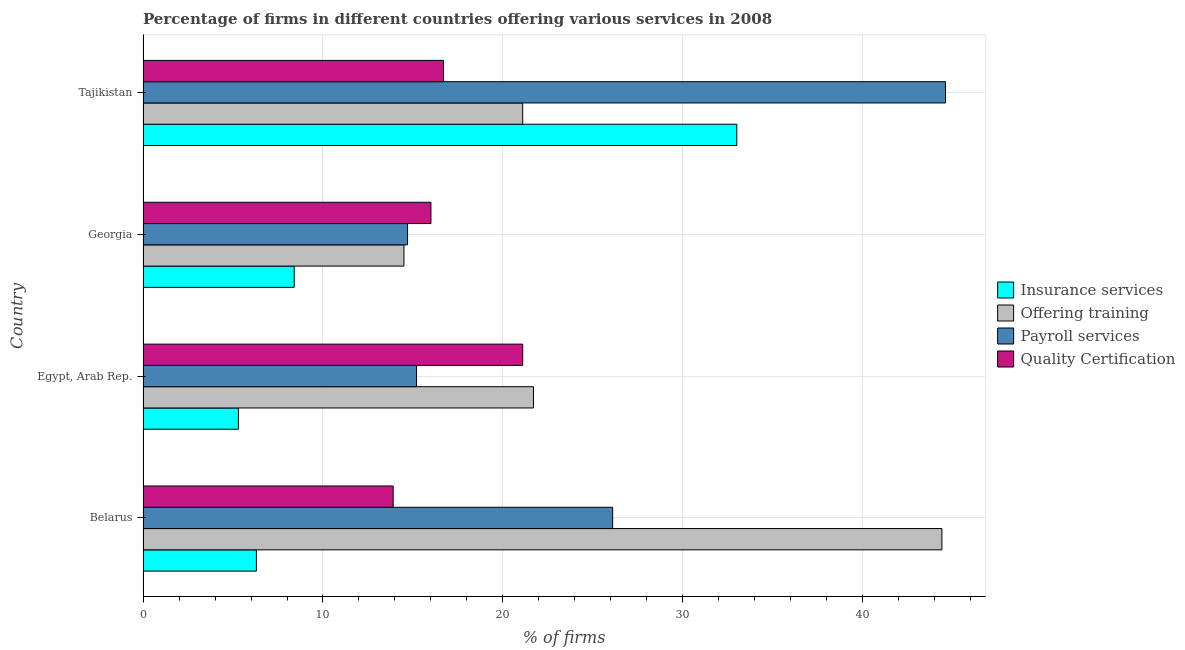How many different coloured bars are there?
Give a very brief answer. 4. Are the number of bars on each tick of the Y-axis equal?
Give a very brief answer. Yes. How many bars are there on the 4th tick from the bottom?
Ensure brevity in your answer.  4. What is the label of the 4th group of bars from the top?
Keep it short and to the point. Belarus. What is the percentage of firms offering quality certification in Tajikistan?
Your response must be concise. 16.7. Across all countries, what is the maximum percentage of firms offering quality certification?
Offer a very short reply. 21.1. Across all countries, what is the minimum percentage of firms offering insurance services?
Make the answer very short. 5.3. In which country was the percentage of firms offering insurance services maximum?
Give a very brief answer. Tajikistan. In which country was the percentage of firms offering quality certification minimum?
Offer a very short reply. Belarus. What is the total percentage of firms offering quality certification in the graph?
Offer a very short reply. 67.7. What is the difference between the percentage of firms offering training in Georgia and that in Tajikistan?
Your answer should be very brief. -6.6. What is the difference between the percentage of firms offering quality certification in Georgia and the percentage of firms offering training in Belarus?
Make the answer very short. -28.4. What is the average percentage of firms offering training per country?
Make the answer very short. 25.43. What is the ratio of the percentage of firms offering payroll services in Belarus to that in Georgia?
Offer a terse response. 1.78. What is the difference between the highest and the lowest percentage of firms offering payroll services?
Make the answer very short. 29.9. Is it the case that in every country, the sum of the percentage of firms offering payroll services and percentage of firms offering quality certification is greater than the sum of percentage of firms offering insurance services and percentage of firms offering training?
Offer a very short reply. Yes. What does the 2nd bar from the top in Belarus represents?
Offer a terse response. Payroll services. What does the 4th bar from the bottom in Tajikistan represents?
Your answer should be very brief. Quality Certification. Is it the case that in every country, the sum of the percentage of firms offering insurance services and percentage of firms offering training is greater than the percentage of firms offering payroll services?
Provide a short and direct response. Yes. How many bars are there?
Offer a terse response. 16. Are all the bars in the graph horizontal?
Ensure brevity in your answer.  Yes. Does the graph contain any zero values?
Keep it short and to the point. No. Does the graph contain grids?
Offer a very short reply. Yes. Where does the legend appear in the graph?
Offer a terse response. Center right. How many legend labels are there?
Give a very brief answer. 4. What is the title of the graph?
Make the answer very short. Percentage of firms in different countries offering various services in 2008. What is the label or title of the X-axis?
Keep it short and to the point. % of firms. What is the label or title of the Y-axis?
Keep it short and to the point. Country. What is the % of firms in Insurance services in Belarus?
Make the answer very short. 6.3. What is the % of firms in Offering training in Belarus?
Offer a terse response. 44.4. What is the % of firms in Payroll services in Belarus?
Your answer should be compact. 26.1. What is the % of firms in Offering training in Egypt, Arab Rep.?
Provide a short and direct response. 21.7. What is the % of firms in Quality Certification in Egypt, Arab Rep.?
Provide a short and direct response. 21.1. What is the % of firms of Insurance services in Georgia?
Provide a short and direct response. 8.4. What is the % of firms of Offering training in Georgia?
Make the answer very short. 14.5. What is the % of firms of Quality Certification in Georgia?
Keep it short and to the point. 16. What is the % of firms in Offering training in Tajikistan?
Your answer should be compact. 21.1. What is the % of firms of Payroll services in Tajikistan?
Provide a short and direct response. 44.6. Across all countries, what is the maximum % of firms in Insurance services?
Ensure brevity in your answer.  33. Across all countries, what is the maximum % of firms of Offering training?
Offer a terse response. 44.4. Across all countries, what is the maximum % of firms of Payroll services?
Give a very brief answer. 44.6. Across all countries, what is the maximum % of firms in Quality Certification?
Provide a short and direct response. 21.1. What is the total % of firms in Offering training in the graph?
Give a very brief answer. 101.7. What is the total % of firms in Payroll services in the graph?
Provide a succinct answer. 100.6. What is the total % of firms of Quality Certification in the graph?
Your answer should be compact. 67.7. What is the difference between the % of firms of Insurance services in Belarus and that in Egypt, Arab Rep.?
Provide a short and direct response. 1. What is the difference between the % of firms in Offering training in Belarus and that in Egypt, Arab Rep.?
Make the answer very short. 22.7. What is the difference between the % of firms of Payroll services in Belarus and that in Egypt, Arab Rep.?
Your response must be concise. 10.9. What is the difference between the % of firms in Offering training in Belarus and that in Georgia?
Keep it short and to the point. 29.9. What is the difference between the % of firms of Quality Certification in Belarus and that in Georgia?
Your response must be concise. -2.1. What is the difference between the % of firms in Insurance services in Belarus and that in Tajikistan?
Make the answer very short. -26.7. What is the difference between the % of firms in Offering training in Belarus and that in Tajikistan?
Your response must be concise. 23.3. What is the difference between the % of firms in Payroll services in Belarus and that in Tajikistan?
Make the answer very short. -18.5. What is the difference between the % of firms of Quality Certification in Belarus and that in Tajikistan?
Your answer should be compact. -2.8. What is the difference between the % of firms in Offering training in Egypt, Arab Rep. and that in Georgia?
Your response must be concise. 7.2. What is the difference between the % of firms of Payroll services in Egypt, Arab Rep. and that in Georgia?
Your answer should be very brief. 0.5. What is the difference between the % of firms in Insurance services in Egypt, Arab Rep. and that in Tajikistan?
Your answer should be compact. -27.7. What is the difference between the % of firms of Offering training in Egypt, Arab Rep. and that in Tajikistan?
Provide a short and direct response. 0.6. What is the difference between the % of firms in Payroll services in Egypt, Arab Rep. and that in Tajikistan?
Offer a terse response. -29.4. What is the difference between the % of firms of Insurance services in Georgia and that in Tajikistan?
Offer a very short reply. -24.6. What is the difference between the % of firms of Payroll services in Georgia and that in Tajikistan?
Give a very brief answer. -29.9. What is the difference between the % of firms in Quality Certification in Georgia and that in Tajikistan?
Make the answer very short. -0.7. What is the difference between the % of firms of Insurance services in Belarus and the % of firms of Offering training in Egypt, Arab Rep.?
Provide a short and direct response. -15.4. What is the difference between the % of firms in Insurance services in Belarus and the % of firms in Payroll services in Egypt, Arab Rep.?
Offer a terse response. -8.9. What is the difference between the % of firms in Insurance services in Belarus and the % of firms in Quality Certification in Egypt, Arab Rep.?
Offer a very short reply. -14.8. What is the difference between the % of firms in Offering training in Belarus and the % of firms in Payroll services in Egypt, Arab Rep.?
Give a very brief answer. 29.2. What is the difference between the % of firms of Offering training in Belarus and the % of firms of Quality Certification in Egypt, Arab Rep.?
Offer a terse response. 23.3. What is the difference between the % of firms of Payroll services in Belarus and the % of firms of Quality Certification in Egypt, Arab Rep.?
Your response must be concise. 5. What is the difference between the % of firms of Offering training in Belarus and the % of firms of Payroll services in Georgia?
Offer a terse response. 29.7. What is the difference between the % of firms of Offering training in Belarus and the % of firms of Quality Certification in Georgia?
Make the answer very short. 28.4. What is the difference between the % of firms in Payroll services in Belarus and the % of firms in Quality Certification in Georgia?
Keep it short and to the point. 10.1. What is the difference between the % of firms of Insurance services in Belarus and the % of firms of Offering training in Tajikistan?
Your answer should be compact. -14.8. What is the difference between the % of firms in Insurance services in Belarus and the % of firms in Payroll services in Tajikistan?
Make the answer very short. -38.3. What is the difference between the % of firms of Insurance services in Belarus and the % of firms of Quality Certification in Tajikistan?
Provide a succinct answer. -10.4. What is the difference between the % of firms in Offering training in Belarus and the % of firms in Quality Certification in Tajikistan?
Your response must be concise. 27.7. What is the difference between the % of firms in Insurance services in Egypt, Arab Rep. and the % of firms in Payroll services in Georgia?
Make the answer very short. -9.4. What is the difference between the % of firms in Offering training in Egypt, Arab Rep. and the % of firms in Quality Certification in Georgia?
Your answer should be compact. 5.7. What is the difference between the % of firms in Insurance services in Egypt, Arab Rep. and the % of firms in Offering training in Tajikistan?
Your answer should be compact. -15.8. What is the difference between the % of firms of Insurance services in Egypt, Arab Rep. and the % of firms of Payroll services in Tajikistan?
Keep it short and to the point. -39.3. What is the difference between the % of firms of Insurance services in Egypt, Arab Rep. and the % of firms of Quality Certification in Tajikistan?
Your response must be concise. -11.4. What is the difference between the % of firms in Offering training in Egypt, Arab Rep. and the % of firms in Payroll services in Tajikistan?
Ensure brevity in your answer.  -22.9. What is the difference between the % of firms in Offering training in Egypt, Arab Rep. and the % of firms in Quality Certification in Tajikistan?
Your answer should be very brief. 5. What is the difference between the % of firms of Insurance services in Georgia and the % of firms of Offering training in Tajikistan?
Offer a terse response. -12.7. What is the difference between the % of firms of Insurance services in Georgia and the % of firms of Payroll services in Tajikistan?
Ensure brevity in your answer.  -36.2. What is the difference between the % of firms in Insurance services in Georgia and the % of firms in Quality Certification in Tajikistan?
Your answer should be compact. -8.3. What is the difference between the % of firms in Offering training in Georgia and the % of firms in Payroll services in Tajikistan?
Your answer should be very brief. -30.1. What is the average % of firms of Insurance services per country?
Your response must be concise. 13.25. What is the average % of firms of Offering training per country?
Ensure brevity in your answer.  25.43. What is the average % of firms of Payroll services per country?
Your answer should be very brief. 25.15. What is the average % of firms in Quality Certification per country?
Keep it short and to the point. 16.93. What is the difference between the % of firms of Insurance services and % of firms of Offering training in Belarus?
Keep it short and to the point. -38.1. What is the difference between the % of firms of Insurance services and % of firms of Payroll services in Belarus?
Your answer should be compact. -19.8. What is the difference between the % of firms in Offering training and % of firms in Quality Certification in Belarus?
Provide a succinct answer. 30.5. What is the difference between the % of firms in Insurance services and % of firms in Offering training in Egypt, Arab Rep.?
Give a very brief answer. -16.4. What is the difference between the % of firms in Insurance services and % of firms in Payroll services in Egypt, Arab Rep.?
Give a very brief answer. -9.9. What is the difference between the % of firms in Insurance services and % of firms in Quality Certification in Egypt, Arab Rep.?
Give a very brief answer. -15.8. What is the difference between the % of firms of Offering training and % of firms of Payroll services in Egypt, Arab Rep.?
Give a very brief answer. 6.5. What is the difference between the % of firms in Payroll services and % of firms in Quality Certification in Egypt, Arab Rep.?
Offer a terse response. -5.9. What is the difference between the % of firms of Insurance services and % of firms of Payroll services in Georgia?
Provide a succinct answer. -6.3. What is the difference between the % of firms of Insurance services and % of firms of Quality Certification in Georgia?
Offer a terse response. -7.6. What is the difference between the % of firms in Offering training and % of firms in Quality Certification in Georgia?
Your response must be concise. -1.5. What is the difference between the % of firms of Payroll services and % of firms of Quality Certification in Georgia?
Ensure brevity in your answer.  -1.3. What is the difference between the % of firms of Insurance services and % of firms of Offering training in Tajikistan?
Provide a succinct answer. 11.9. What is the difference between the % of firms of Offering training and % of firms of Payroll services in Tajikistan?
Provide a short and direct response. -23.5. What is the difference between the % of firms in Offering training and % of firms in Quality Certification in Tajikistan?
Give a very brief answer. 4.4. What is the difference between the % of firms of Payroll services and % of firms of Quality Certification in Tajikistan?
Ensure brevity in your answer.  27.9. What is the ratio of the % of firms of Insurance services in Belarus to that in Egypt, Arab Rep.?
Provide a succinct answer. 1.19. What is the ratio of the % of firms in Offering training in Belarus to that in Egypt, Arab Rep.?
Offer a very short reply. 2.05. What is the ratio of the % of firms of Payroll services in Belarus to that in Egypt, Arab Rep.?
Offer a terse response. 1.72. What is the ratio of the % of firms of Quality Certification in Belarus to that in Egypt, Arab Rep.?
Offer a very short reply. 0.66. What is the ratio of the % of firms of Insurance services in Belarus to that in Georgia?
Your answer should be compact. 0.75. What is the ratio of the % of firms of Offering training in Belarus to that in Georgia?
Provide a succinct answer. 3.06. What is the ratio of the % of firms in Payroll services in Belarus to that in Georgia?
Keep it short and to the point. 1.78. What is the ratio of the % of firms of Quality Certification in Belarus to that in Georgia?
Your response must be concise. 0.87. What is the ratio of the % of firms in Insurance services in Belarus to that in Tajikistan?
Ensure brevity in your answer.  0.19. What is the ratio of the % of firms of Offering training in Belarus to that in Tajikistan?
Make the answer very short. 2.1. What is the ratio of the % of firms of Payroll services in Belarus to that in Tajikistan?
Your answer should be very brief. 0.59. What is the ratio of the % of firms in Quality Certification in Belarus to that in Tajikistan?
Your answer should be compact. 0.83. What is the ratio of the % of firms of Insurance services in Egypt, Arab Rep. to that in Georgia?
Your response must be concise. 0.63. What is the ratio of the % of firms in Offering training in Egypt, Arab Rep. to that in Georgia?
Ensure brevity in your answer.  1.5. What is the ratio of the % of firms in Payroll services in Egypt, Arab Rep. to that in Georgia?
Provide a succinct answer. 1.03. What is the ratio of the % of firms in Quality Certification in Egypt, Arab Rep. to that in Georgia?
Provide a short and direct response. 1.32. What is the ratio of the % of firms of Insurance services in Egypt, Arab Rep. to that in Tajikistan?
Your answer should be very brief. 0.16. What is the ratio of the % of firms of Offering training in Egypt, Arab Rep. to that in Tajikistan?
Your response must be concise. 1.03. What is the ratio of the % of firms of Payroll services in Egypt, Arab Rep. to that in Tajikistan?
Make the answer very short. 0.34. What is the ratio of the % of firms of Quality Certification in Egypt, Arab Rep. to that in Tajikistan?
Give a very brief answer. 1.26. What is the ratio of the % of firms in Insurance services in Georgia to that in Tajikistan?
Provide a succinct answer. 0.25. What is the ratio of the % of firms in Offering training in Georgia to that in Tajikistan?
Give a very brief answer. 0.69. What is the ratio of the % of firms in Payroll services in Georgia to that in Tajikistan?
Offer a terse response. 0.33. What is the ratio of the % of firms in Quality Certification in Georgia to that in Tajikistan?
Provide a short and direct response. 0.96. What is the difference between the highest and the second highest % of firms of Insurance services?
Offer a very short reply. 24.6. What is the difference between the highest and the second highest % of firms in Offering training?
Keep it short and to the point. 22.7. What is the difference between the highest and the lowest % of firms in Insurance services?
Provide a succinct answer. 27.7. What is the difference between the highest and the lowest % of firms of Offering training?
Make the answer very short. 29.9. What is the difference between the highest and the lowest % of firms in Payroll services?
Ensure brevity in your answer.  29.9. What is the difference between the highest and the lowest % of firms in Quality Certification?
Provide a succinct answer. 7.2. 